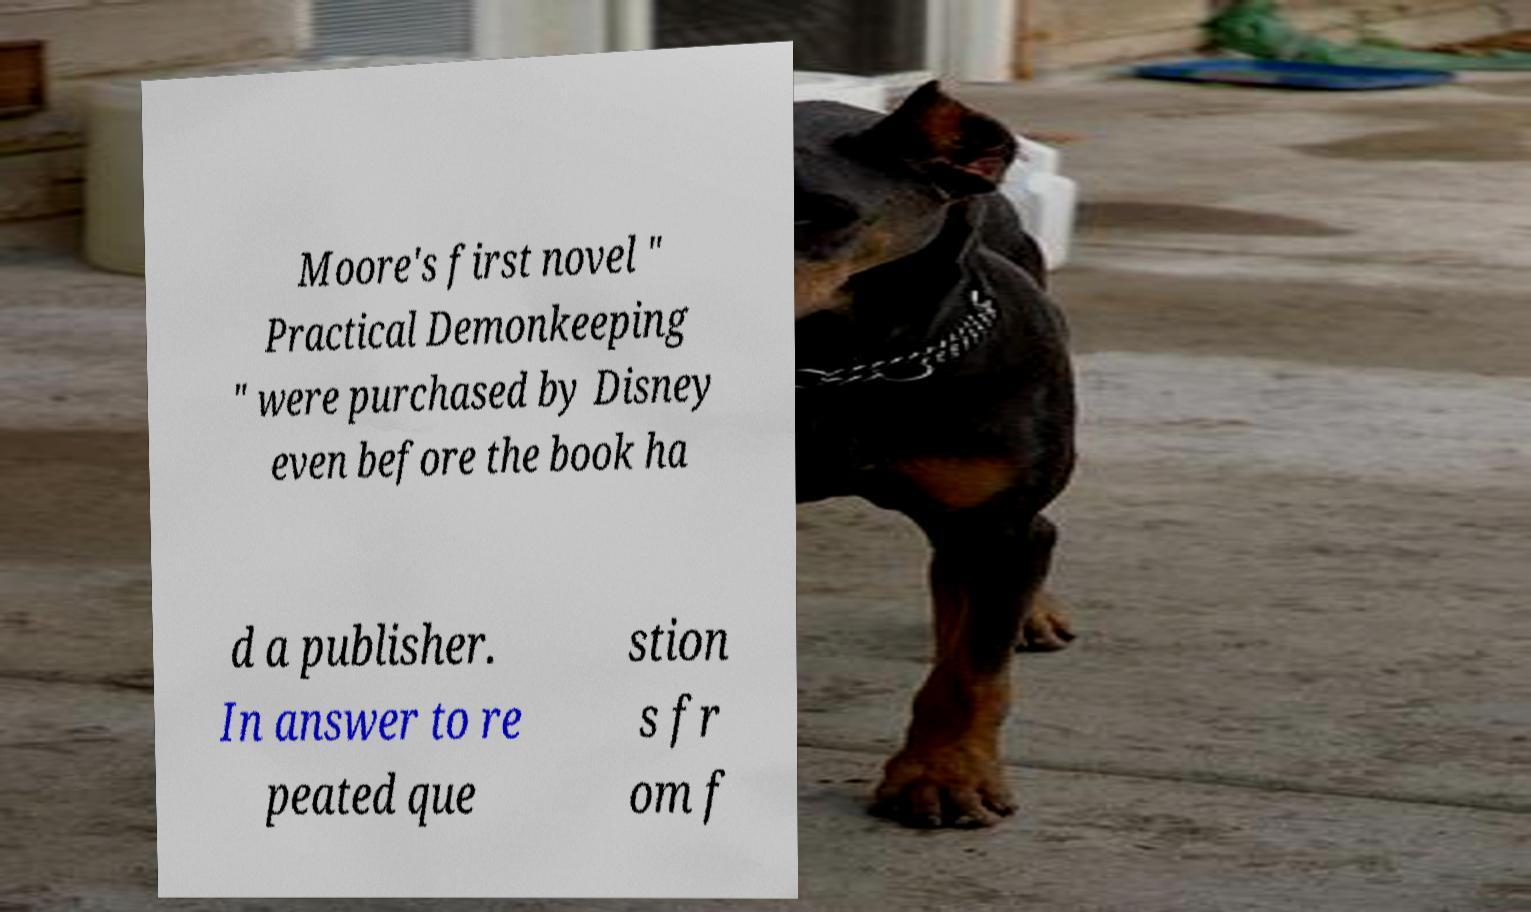Please read and relay the text visible in this image. What does it say? Moore's first novel " Practical Demonkeeping " were purchased by Disney even before the book ha d a publisher. In answer to re peated que stion s fr om f 